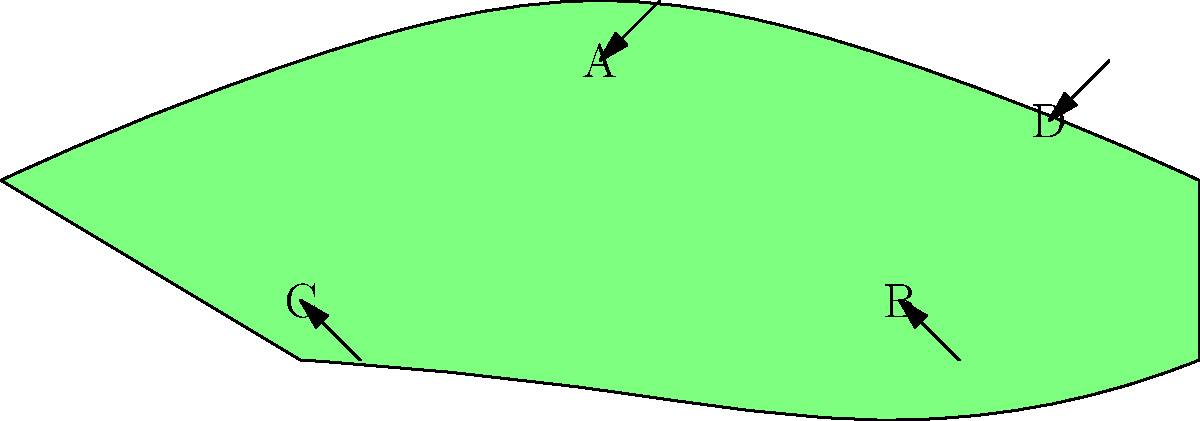As a Venezuelan conservationist and reptile enthusiast, you're studying the anatomy of a green iguana. In the cross-section diagram above, which labeled part represents the iguana's digestive tract, crucial for processing the plant matter that forms the bulk of its diet? To answer this question, let's analyze each labeled part of the iguana's anatomy:

1. Part A: This is located in the upper portion of the body cavity. Given its position, this is likely the iguana's lungs, which are essential for respiration but not directly involved in digestion.

2. Part B: This is positioned in the lower part of the body cavity, extending along much of the iguana's length. This location and size are characteristic of the digestive tract in reptiles, including iguanas. The digestive tract is crucial for processing the leaves, flowers, and fruits that make up the green iguana's herbivorous diet.

3. Part C: This is located in the lower front portion of the body cavity. Given its position, this could represent the iguana's liver, which aids in digestion but is not the primary digestive organ.

4. Part D: This small structure near the tail end of the iguana likely represents the cloaca, which is involved in waste elimination and reproduction, but not in the main digestive process.

Given this analysis, the part that represents the iguana's digestive tract, crucial for processing plant matter, is Part B.
Answer: B 